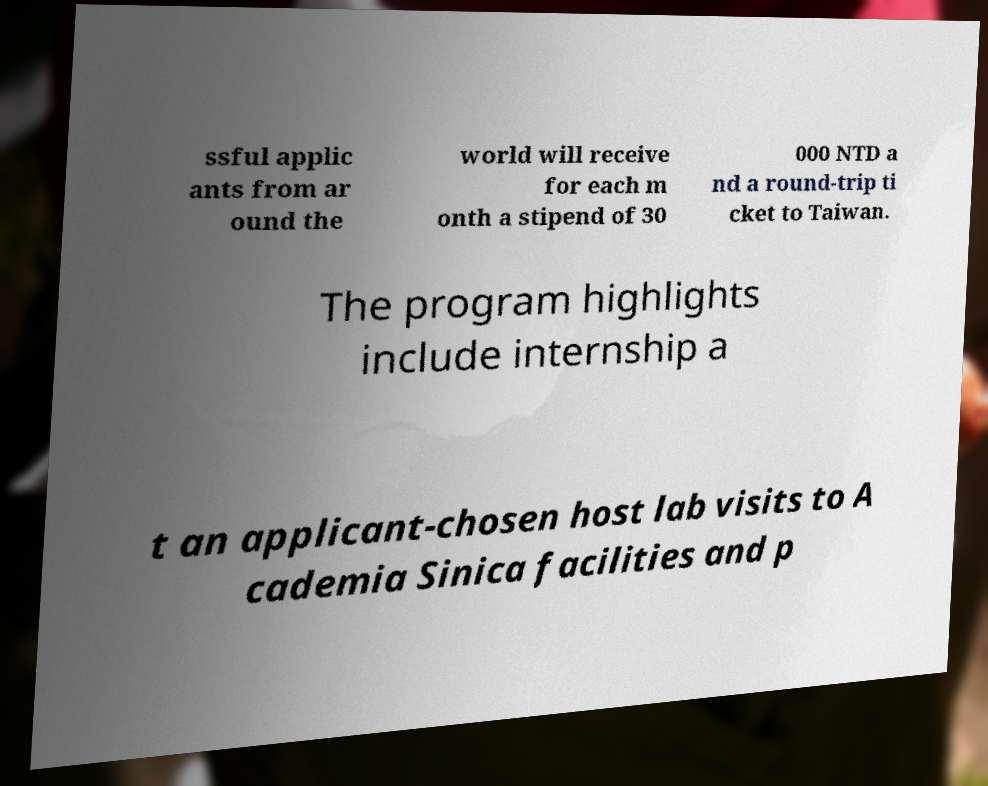For documentation purposes, I need the text within this image transcribed. Could you provide that? ssful applic ants from ar ound the world will receive for each m onth a stipend of 30 000 NTD a nd a round-trip ti cket to Taiwan. The program highlights include internship a t an applicant-chosen host lab visits to A cademia Sinica facilities and p 